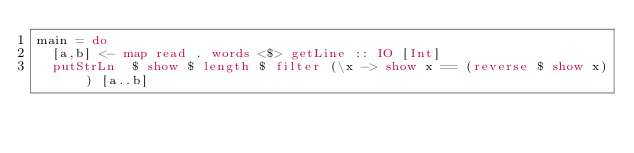<code> <loc_0><loc_0><loc_500><loc_500><_Haskell_>main = do
  [a,b] <- map read . words <$> getLine :: IO [Int]
  putStrLn  $ show $ length $ filter (\x -> show x == (reverse $ show x)) [a..b]
</code> 